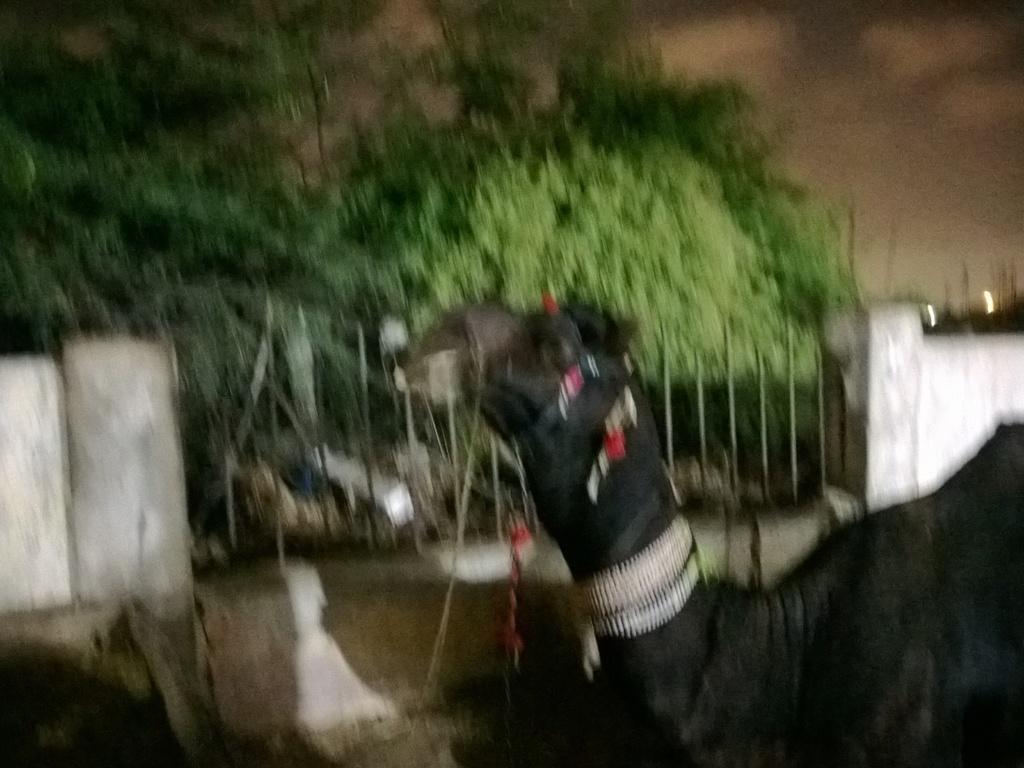How would you summarize this image in a sentence or two? In this picture we can see a camel in the front, in the background there are some trees and a wall, there is the sky at the right top of the picture. 